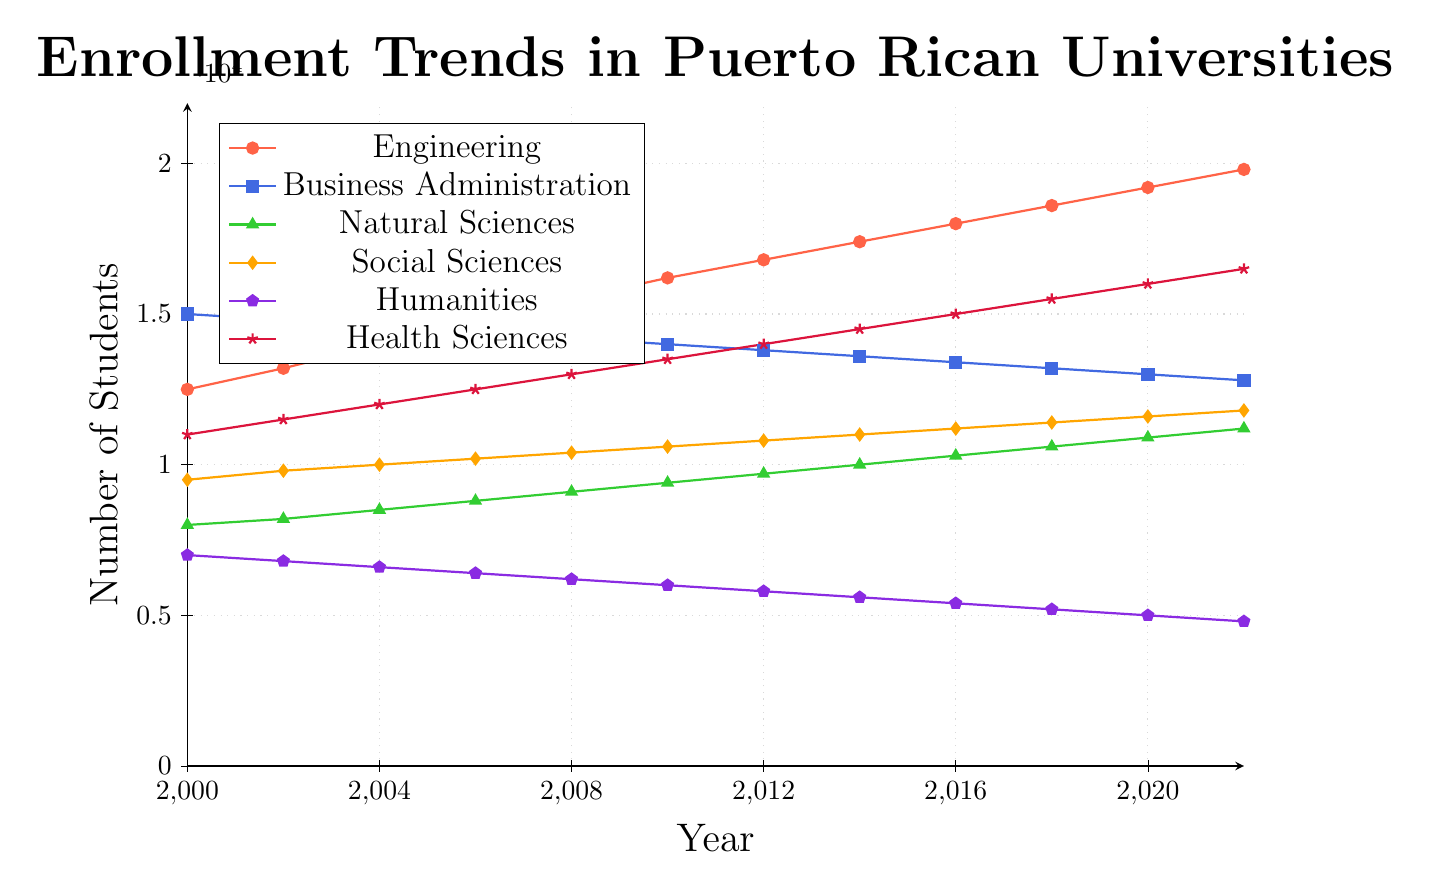Which major had the highest enrollment in 2000? In the figure, the major with the highest enrollment in 2000 is shown with the highest point on the Y-axis for that year. Business Administration has the enrollment of 15000, which is the highest among all.
Answer: Business Administration Which major experienced a decline in enrollment over the years? In the figure, Humanities starts at 7000 in 2000 and declines steadily to 4800 by 2022. The downward trend visually represents this decline.
Answer: Humanities Which major saw the most consistent increase in enrollment from 2000 to 2022? By examining the trends from 2000 to 2022, Engineering shows a consistent upward trend from 12500 in 2000 to 19800 in 2022 without any drops.
Answer: Engineering What's the total enrollment in the Health Sciences in 2010 and 2022 combined? In 2010, the enrollment is 13500, and in 2022, it is 16500. Summing these values: 13500 + 16500 = 30000.
Answer: 30000 Did any major have a year where their enrollment was stable (no increase or decrease)? Examining the data, no major had a completely stable year where enrollment did not change at all.
Answer: No Which major had the smallest enrollment in 2022? In 2022, Humanities has the smallest enrollment with 4800 students. This is visually identifiable as the lowest point in that year.
Answer: Humanities How much did the enrollment in Natural Sciences grow from 2000 to 2022? In 2000, the enrollment was 8000 and in 2022 it was 11200. The growth is 11200 - 8000 = 3200.
Answer: 3200 Compare the enrollment trends of Social Sciences and Business Administration. Which one had more students in 2016? From the figure, Social Sciences had 11200 students in 2016, whereas Business Administration had 13400 students. Thus, Business Administration had more students.
Answer: Business Administration Which major had a noticeable peak around 2008? The figure shows that the Health Sciences had a noticeable peak, rising from 11000 in 2000 to around 13000 in 2008 and then continuing to rise till 2022.
Answer: Health Sciences Looking at the trend lines, which major seems to be the most popular in recent years? Engineering shows a steady rise and reaches 19800 in 2022, making it the most popular major in recent years.
Answer: Engineering 